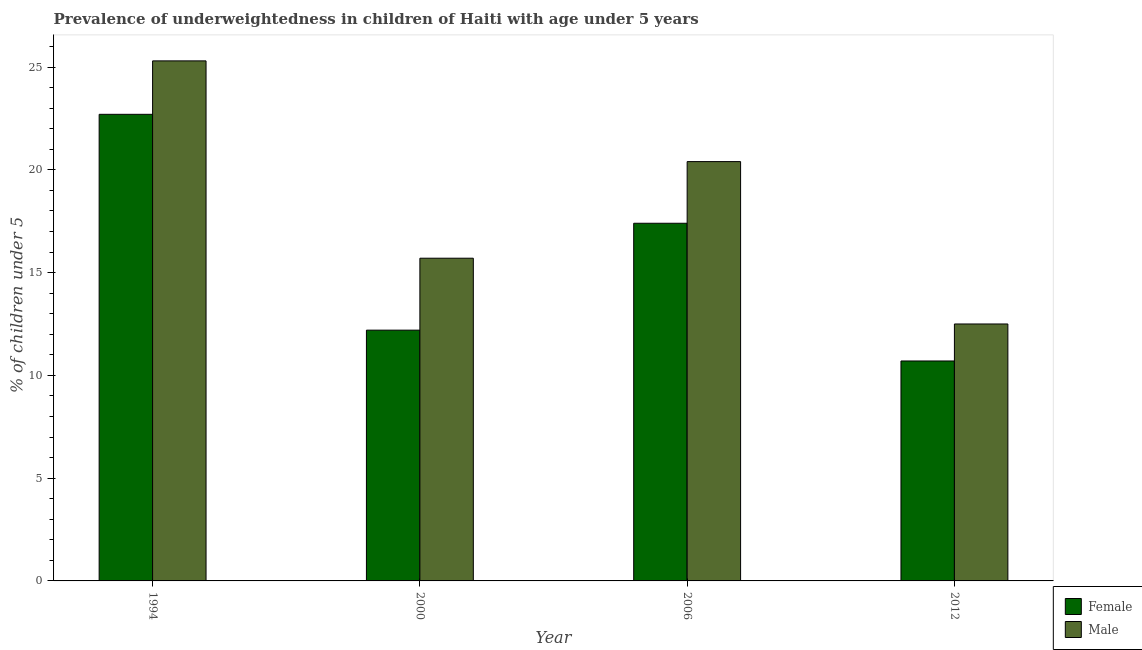How many groups of bars are there?
Offer a terse response. 4. How many bars are there on the 3rd tick from the left?
Ensure brevity in your answer.  2. What is the label of the 4th group of bars from the left?
Give a very brief answer. 2012. In how many cases, is the number of bars for a given year not equal to the number of legend labels?
Offer a very short reply. 0. What is the percentage of underweighted female children in 2006?
Your answer should be very brief. 17.4. Across all years, what is the maximum percentage of underweighted female children?
Ensure brevity in your answer.  22.7. Across all years, what is the minimum percentage of underweighted female children?
Offer a terse response. 10.7. In which year was the percentage of underweighted male children maximum?
Offer a terse response. 1994. In which year was the percentage of underweighted female children minimum?
Your response must be concise. 2012. What is the total percentage of underweighted female children in the graph?
Ensure brevity in your answer.  63. What is the difference between the percentage of underweighted female children in 1994 and that in 2006?
Your answer should be compact. 5.3. What is the difference between the percentage of underweighted male children in 1994 and the percentage of underweighted female children in 2000?
Offer a terse response. 9.6. What is the average percentage of underweighted male children per year?
Provide a short and direct response. 18.47. In the year 1994, what is the difference between the percentage of underweighted male children and percentage of underweighted female children?
Your response must be concise. 0. What is the ratio of the percentage of underweighted female children in 2000 to that in 2006?
Make the answer very short. 0.7. Is the percentage of underweighted male children in 1994 less than that in 2000?
Your answer should be compact. No. Is the difference between the percentage of underweighted male children in 2000 and 2006 greater than the difference between the percentage of underweighted female children in 2000 and 2006?
Keep it short and to the point. No. What is the difference between the highest and the second highest percentage of underweighted female children?
Ensure brevity in your answer.  5.3. What is the difference between the highest and the lowest percentage of underweighted female children?
Make the answer very short. 12. Is the sum of the percentage of underweighted female children in 2000 and 2012 greater than the maximum percentage of underweighted male children across all years?
Provide a succinct answer. Yes. What does the 1st bar from the right in 2012 represents?
Your answer should be compact. Male. Are all the bars in the graph horizontal?
Provide a succinct answer. No. How many years are there in the graph?
Provide a short and direct response. 4. What is the difference between two consecutive major ticks on the Y-axis?
Give a very brief answer. 5. How many legend labels are there?
Give a very brief answer. 2. What is the title of the graph?
Give a very brief answer. Prevalence of underweightedness in children of Haiti with age under 5 years. What is the label or title of the X-axis?
Give a very brief answer. Year. What is the label or title of the Y-axis?
Provide a short and direct response.  % of children under 5. What is the  % of children under 5 in Female in 1994?
Give a very brief answer. 22.7. What is the  % of children under 5 of Male in 1994?
Make the answer very short. 25.3. What is the  % of children under 5 in Female in 2000?
Keep it short and to the point. 12.2. What is the  % of children under 5 in Male in 2000?
Make the answer very short. 15.7. What is the  % of children under 5 in Female in 2006?
Give a very brief answer. 17.4. What is the  % of children under 5 of Male in 2006?
Offer a very short reply. 20.4. What is the  % of children under 5 of Female in 2012?
Your answer should be very brief. 10.7. Across all years, what is the maximum  % of children under 5 in Female?
Offer a very short reply. 22.7. Across all years, what is the maximum  % of children under 5 in Male?
Keep it short and to the point. 25.3. Across all years, what is the minimum  % of children under 5 in Female?
Your response must be concise. 10.7. What is the total  % of children under 5 in Male in the graph?
Provide a short and direct response. 73.9. What is the difference between the  % of children under 5 in Female in 1994 and that in 2000?
Your answer should be compact. 10.5. What is the difference between the  % of children under 5 in Female in 1994 and that in 2006?
Give a very brief answer. 5.3. What is the difference between the  % of children under 5 in Male in 1994 and that in 2006?
Your answer should be compact. 4.9. What is the difference between the  % of children under 5 in Female in 1994 and that in 2012?
Your answer should be very brief. 12. What is the difference between the  % of children under 5 of Male in 2000 and that in 2012?
Your answer should be compact. 3.2. What is the difference between the  % of children under 5 of Female in 2006 and that in 2012?
Your answer should be very brief. 6.7. What is the difference between the  % of children under 5 of Female in 1994 and the  % of children under 5 of Male in 2012?
Provide a short and direct response. 10.2. What is the difference between the  % of children under 5 of Female in 2006 and the  % of children under 5 of Male in 2012?
Offer a very short reply. 4.9. What is the average  % of children under 5 of Female per year?
Your response must be concise. 15.75. What is the average  % of children under 5 of Male per year?
Your answer should be compact. 18.48. In the year 1994, what is the difference between the  % of children under 5 of Female and  % of children under 5 of Male?
Ensure brevity in your answer.  -2.6. In the year 2000, what is the difference between the  % of children under 5 of Female and  % of children under 5 of Male?
Keep it short and to the point. -3.5. In the year 2012, what is the difference between the  % of children under 5 in Female and  % of children under 5 in Male?
Make the answer very short. -1.8. What is the ratio of the  % of children under 5 of Female in 1994 to that in 2000?
Provide a succinct answer. 1.86. What is the ratio of the  % of children under 5 of Male in 1994 to that in 2000?
Keep it short and to the point. 1.61. What is the ratio of the  % of children under 5 of Female in 1994 to that in 2006?
Provide a succinct answer. 1.3. What is the ratio of the  % of children under 5 in Male in 1994 to that in 2006?
Ensure brevity in your answer.  1.24. What is the ratio of the  % of children under 5 in Female in 1994 to that in 2012?
Give a very brief answer. 2.12. What is the ratio of the  % of children under 5 in Male in 1994 to that in 2012?
Your answer should be very brief. 2.02. What is the ratio of the  % of children under 5 in Female in 2000 to that in 2006?
Provide a succinct answer. 0.7. What is the ratio of the  % of children under 5 in Male in 2000 to that in 2006?
Give a very brief answer. 0.77. What is the ratio of the  % of children under 5 in Female in 2000 to that in 2012?
Make the answer very short. 1.14. What is the ratio of the  % of children under 5 of Male in 2000 to that in 2012?
Offer a very short reply. 1.26. What is the ratio of the  % of children under 5 in Female in 2006 to that in 2012?
Ensure brevity in your answer.  1.63. What is the ratio of the  % of children under 5 of Male in 2006 to that in 2012?
Your response must be concise. 1.63. What is the difference between the highest and the second highest  % of children under 5 in Female?
Ensure brevity in your answer.  5.3. What is the difference between the highest and the second highest  % of children under 5 of Male?
Keep it short and to the point. 4.9. What is the difference between the highest and the lowest  % of children under 5 in Male?
Provide a succinct answer. 12.8. 